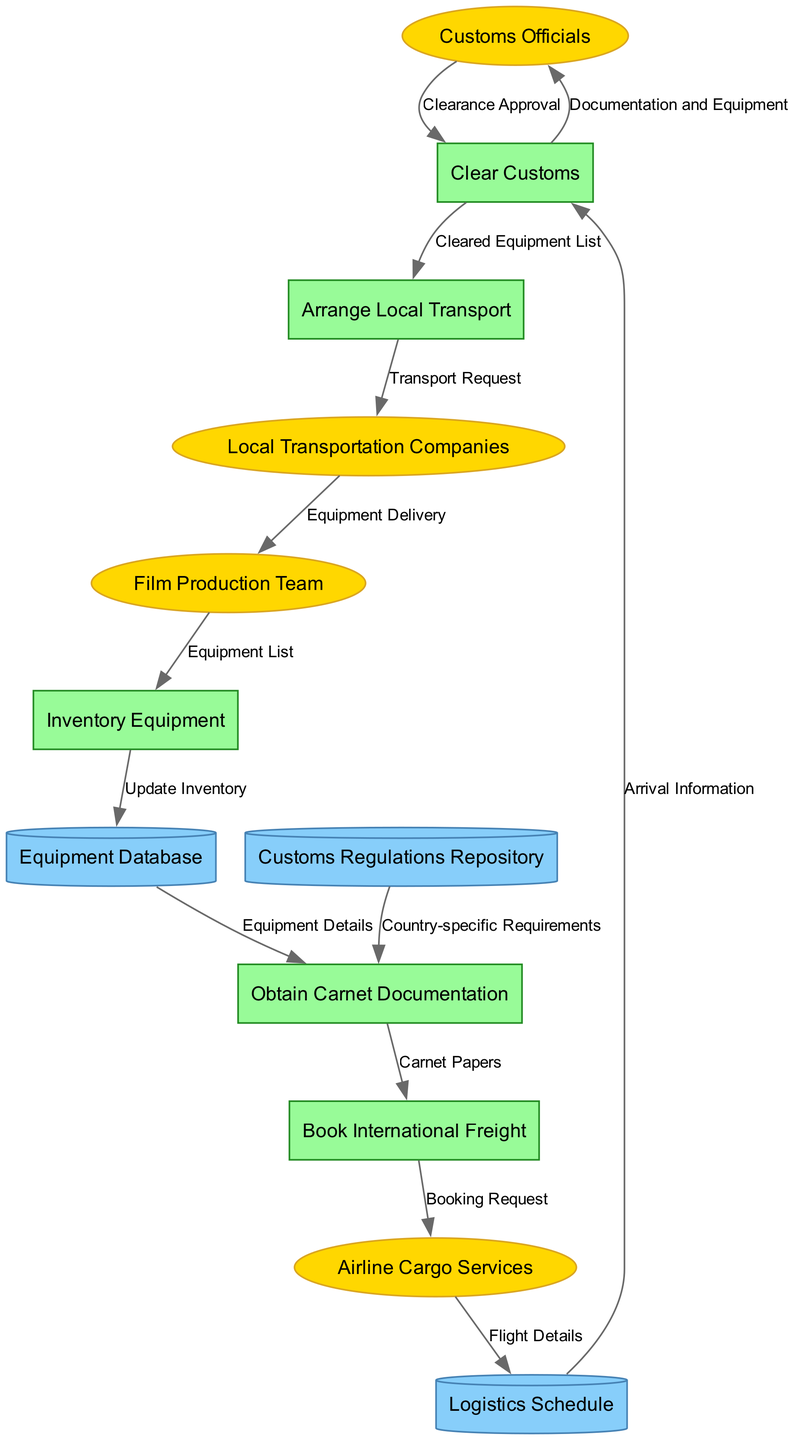How many external entities are present in the diagram? The diagram lists four external entities. These are Customs Officials, Airline Cargo Services, Local Transportation Companies, and Film Production Team. We simply count each entity represented in the diagram.
Answer: 4 What does the Film Production Team provide to the Inventory Equipment process? The Film Production Team provides an Equipment List to the Inventory Equipment process. This relationship is directly shown in the data flow between these two nodes.
Answer: Equipment List Which process is responsible for clearing customs? The process responsible for clearing customs is called "Clear Customs." This is explicitly labeled in the diagram.
Answer: Clear Customs What is the final output of the Arrange Local Transport process? The final output of the Arrange Local Transport process is a Transport Request sent to Local Transportation Companies. This is indicated by the data flow leading from Arrange Local Transport to Local Transportation Companies.
Answer: Transport Request Which data store provides information for obtaining carnet documentation? The data store that provides information for obtaining carnet documentation is the Customs Regulations Repository. This flow is depicted connecting the repository to the Obtain Carnet Documentation process.
Answer: Customs Regulations Repository How many data flows are there between the nodes in the diagram? By counting all the directed edges in the diagram, there are a total of thirteen data flows present. Each flow connects various nodes which represents a form of data transmission.
Answer: 13 What is required before booking international freight? Before booking international freight, it is necessary to obtain carnet documentation, indicated by the flow leading from Obtain Carnet Documentation to Book International Freight.
Answer: Obtain Carnet Documentation Who approves the customs clearance? Customs Officials are responsible for approving the customs clearance, as shown by the feedback loop from Customs Officials back to the Clear Customs process.
Answer: Customs Officials What type of data store is Equipment Database? The Equipment Database is classified as a cylinder shaped data store, indicating it holds data necessary for the processes in the diagram.
Answer: Cylinder 